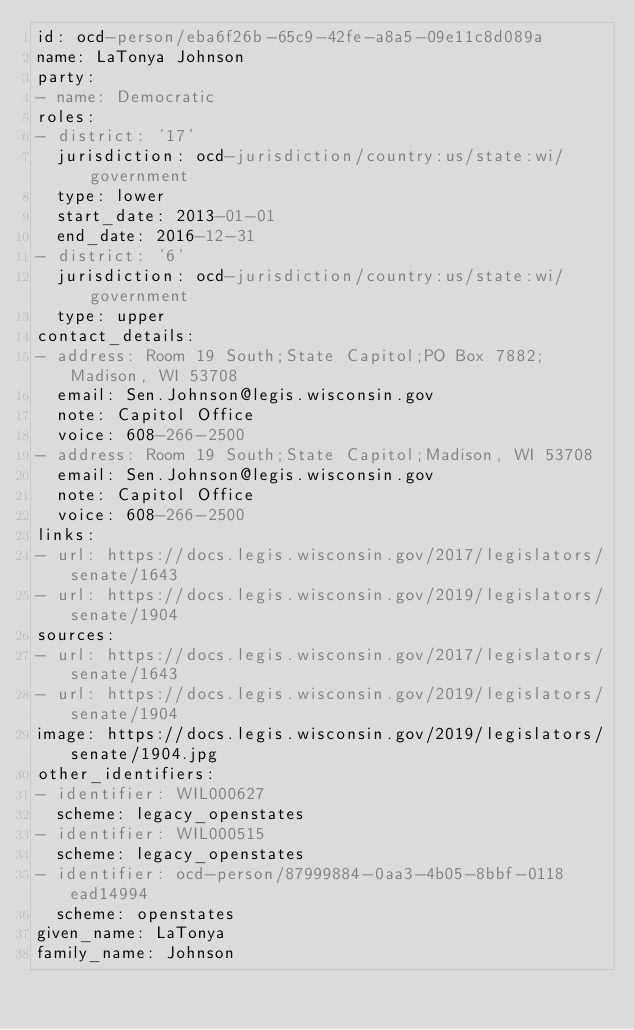Convert code to text. <code><loc_0><loc_0><loc_500><loc_500><_YAML_>id: ocd-person/eba6f26b-65c9-42fe-a8a5-09e11c8d089a
name: LaTonya Johnson
party:
- name: Democratic
roles:
- district: '17'
  jurisdiction: ocd-jurisdiction/country:us/state:wi/government
  type: lower
  start_date: 2013-01-01
  end_date: 2016-12-31
- district: '6'
  jurisdiction: ocd-jurisdiction/country:us/state:wi/government
  type: upper
contact_details:
- address: Room 19 South;State Capitol;PO Box 7882;Madison, WI 53708
  email: Sen.Johnson@legis.wisconsin.gov
  note: Capitol Office
  voice: 608-266-2500
- address: Room 19 South;State Capitol;Madison, WI 53708
  email: Sen.Johnson@legis.wisconsin.gov
  note: Capitol Office
  voice: 608-266-2500
links:
- url: https://docs.legis.wisconsin.gov/2017/legislators/senate/1643
- url: https://docs.legis.wisconsin.gov/2019/legislators/senate/1904
sources:
- url: https://docs.legis.wisconsin.gov/2017/legislators/senate/1643
- url: https://docs.legis.wisconsin.gov/2019/legislators/senate/1904
image: https://docs.legis.wisconsin.gov/2019/legislators/senate/1904.jpg
other_identifiers:
- identifier: WIL000627
  scheme: legacy_openstates
- identifier: WIL000515
  scheme: legacy_openstates
- identifier: ocd-person/87999884-0aa3-4b05-8bbf-0118ead14994
  scheme: openstates
given_name: LaTonya
family_name: Johnson
</code> 